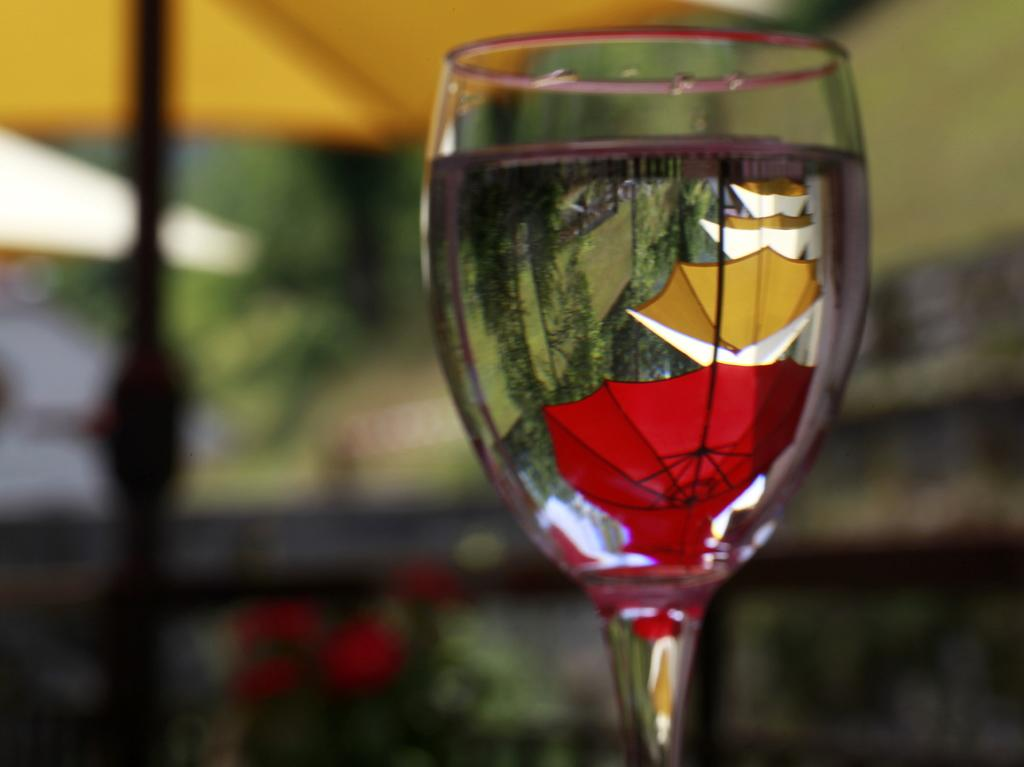What object is present in the image that can hold a liquid? There is a glass in the image. What can be seen in the reflection of the glass? The glass has a reflection of umbrellas. How would you describe the background of the image? The background of the image is blurred. What type of mountain is visible in the background of the image? There is no mountain visible in the background of the image; the background is blurred. 